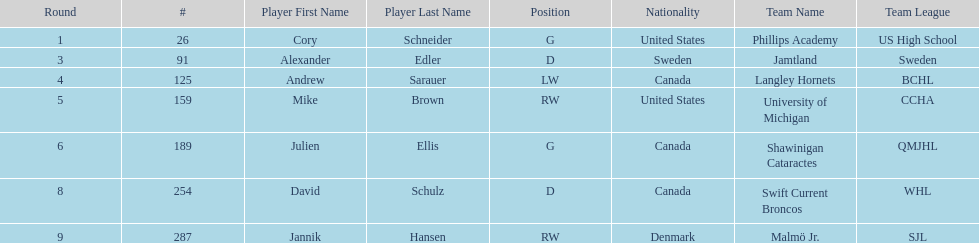What is the name of the last player on this chart? Jannik Hansen (RW). 